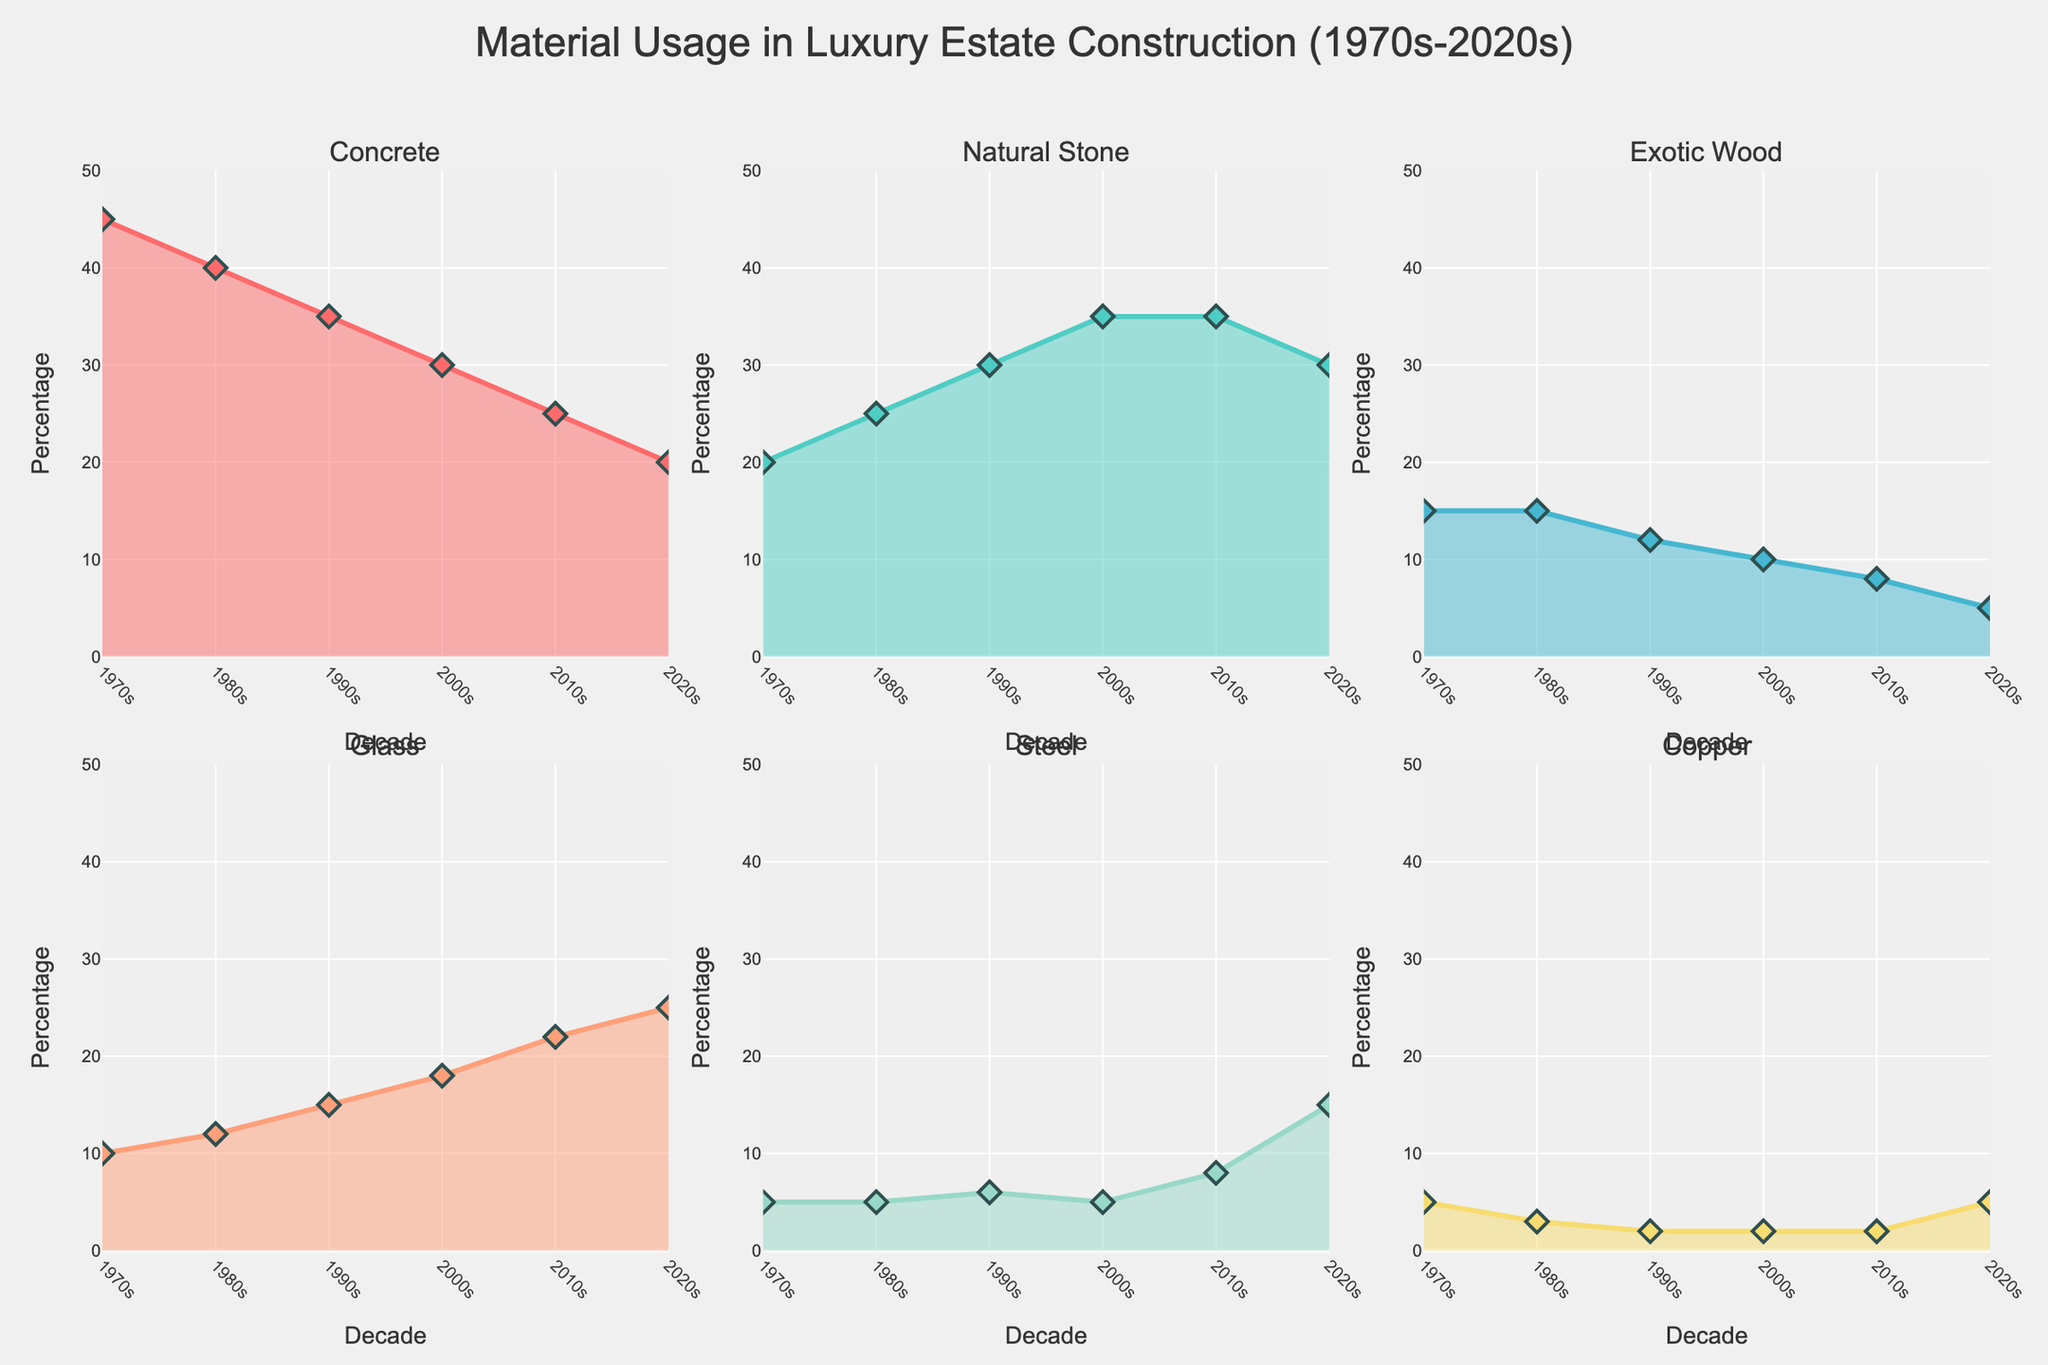What is the dominant material used in the 1970s? By observing the data for the 1970s, we can see that Concrete has the highest percentage value.
Answer: Concrete Which material usage increased the most from the 2010s to the 2020s? By comparing the percentages, Glass increased from 22% to 25%, showing the greatest increase.
Answer: Glass How did the usage of Natural Stone change from the 1970s to the 2020s? The percentages for Natural Stone in the 1970s and 2020s are 20% and 30%, respectively. The difference is 30% - 20% = 10%.
Answer: Increased by 10% Which decade saw the highest usage of Steel? By examining the data, the highest percentage of Steel is seen in the 2020s, where it reaches 15%.
Answer: 2020s What is the trend for Concrete usage over the decades? By observing Concrete percentages, we can see a decreasing trend: 45% in the 1970s, 40% in the 1980s, 35% in the 1990s, 30% in the 2000s, 25% in the 2010s, and 20% in the 2020s.
Answer: Decreasing Compare the usage of Exotic Wood and Copper in the 2000s. Which one is used more? In the 2000s, Exotic Wood is at 10% and Copper is at 2%. Therefore, Exotic Wood is used more.
Answer: Exotic Wood Which material shows the most consistent usage percentage over the decades? By checking the variations, Copper shows the most consistent usage, remaining between 2-5% throughout the decades.
Answer: Copper What material shows the largest percentage difference between two consecutive decades? By examining the data, the largest percentage difference is in Glass from the 2010s (22%) to the 2020s (25%), which is a 3% increase.
Answer: Glass What is the average percentage usage of Glass between the 1970s and the 2020s? Sum of percentages of Glass: 10 + 12 + 15 + 18 + 22 + 25 = 102. Number of decades = 6. Average = 102 / 6 = 17%.
Answer: 17% Which decade showed the least usage of Exotic Wood? By checking the data, the 2020s show the least usage of Exotic Wood at 5%.
Answer: 2020s 